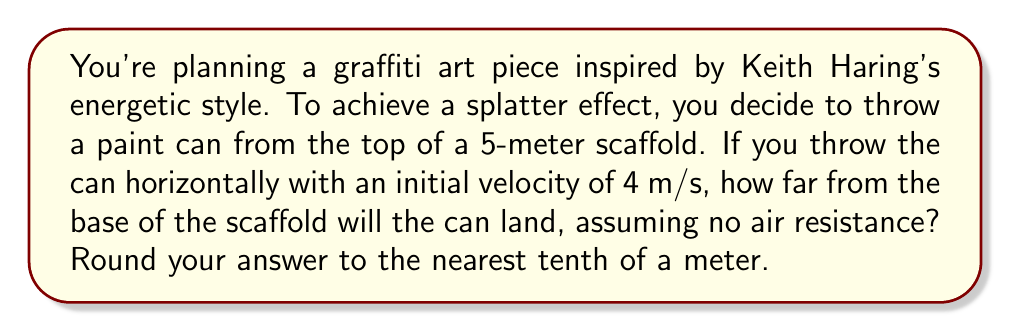Help me with this question. Let's approach this step-by-step using the principles of projectile motion:

1) In projectile motion, horizontal and vertical motions are independent. We'll analyze them separately.

2) Horizontal motion:
   - Initial horizontal velocity: $v_x = 4$ m/s
   - Horizontal acceleration: $a_x = 0$ (no acceleration in horizontal direction)
   - Distance formula: $x = v_x t$

3) Vertical motion:
   - Initial vertical velocity: $v_y = 0$ m/s (thrown horizontally)
   - Vertical acceleration: $a_y = g = 9.8$ m/s² (acceleration due to gravity)
   - Distance formula: $y = \frac{1}{2}gt^2$

4) We need to find the time it takes for the can to hit the ground. We can use the vertical motion equation:
   
   $5 = \frac{1}{2}(9.8)t^2$
   
   $10 = 9.8t^2$
   
   $t^2 = \frac{10}{9.8} = 1.0204$
   
   $t = \sqrt{1.0204} = 1.0102$ seconds

5) Now that we have the time, we can use it in the horizontal motion equation:

   $x = v_x t = 4 * 1.0102 = 4.0408$ meters

6) Rounding to the nearest tenth:

   $4.0408 \approx 4.0$ meters
Answer: 4.0 m 